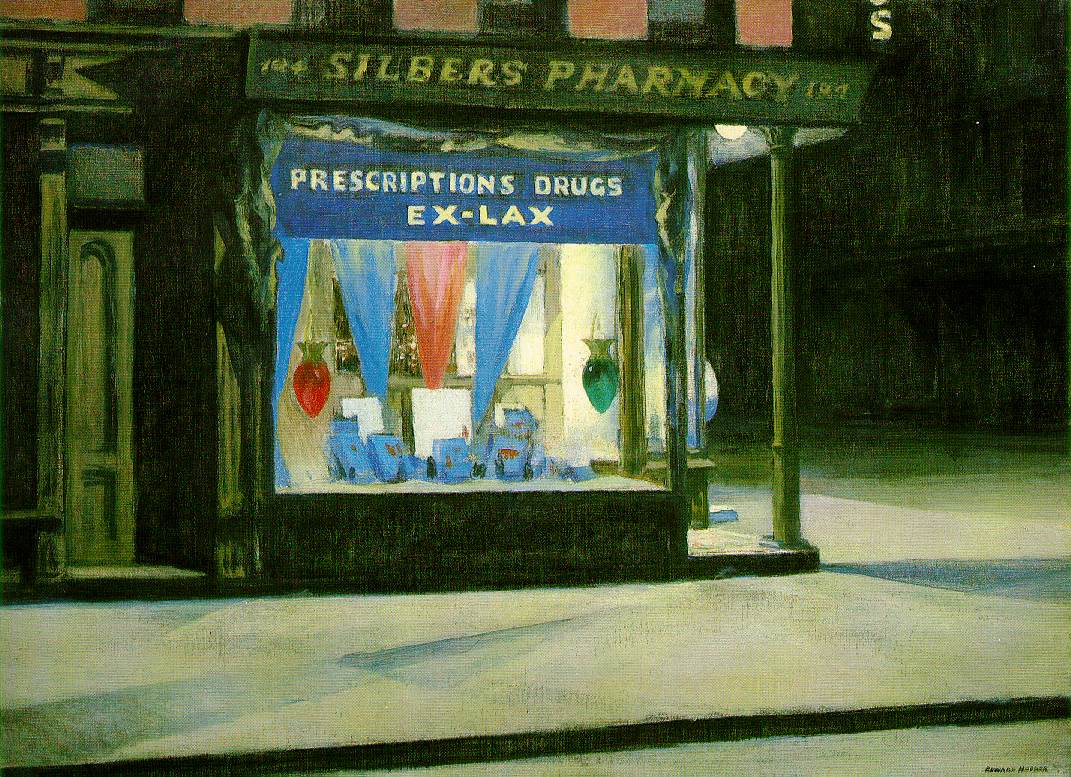What era might this painting depict, and what clues lead you to that conclusion? This painting likely depicts the early to mid-20th century, an inference drawn from multiple clues in the image. The style of the signage, the design of the pharmacy window, and the types of goods displayed, such as Ex-Lax, which was popular during that time, all suggest this period. Additionally, the architecture of the storefront and the lighting style are indicative of urban design trends from the first half of the 20th century. 